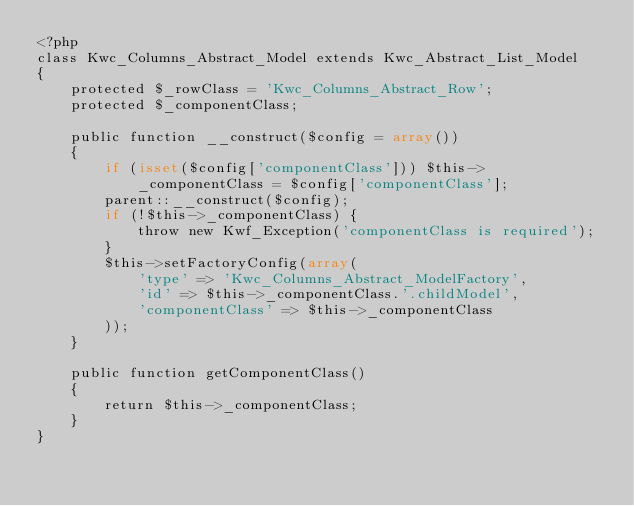Convert code to text. <code><loc_0><loc_0><loc_500><loc_500><_PHP_><?php
class Kwc_Columns_Abstract_Model extends Kwc_Abstract_List_Model
{
    protected $_rowClass = 'Kwc_Columns_Abstract_Row';
    protected $_componentClass;

    public function __construct($config = array())
    {
        if (isset($config['componentClass'])) $this->_componentClass = $config['componentClass'];
        parent::__construct($config);
        if (!$this->_componentClass) {
            throw new Kwf_Exception('componentClass is required');
        }
        $this->setFactoryConfig(array(
            'type' => 'Kwc_Columns_Abstract_ModelFactory',
            'id' => $this->_componentClass.'.childModel',
            'componentClass' => $this->_componentClass
        ));
    }

    public function getComponentClass()
    {
        return $this->_componentClass;
    }
}
</code> 